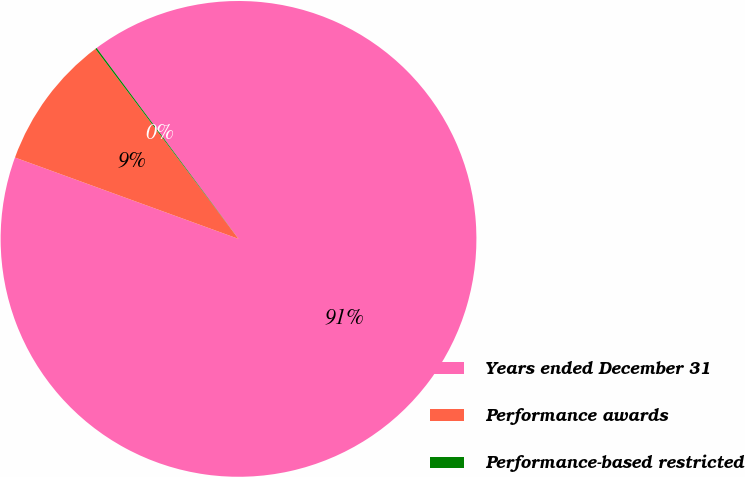Convert chart. <chart><loc_0><loc_0><loc_500><loc_500><pie_chart><fcel>Years ended December 31<fcel>Performance awards<fcel>Performance-based restricted<nl><fcel>90.73%<fcel>9.17%<fcel>0.1%<nl></chart> 